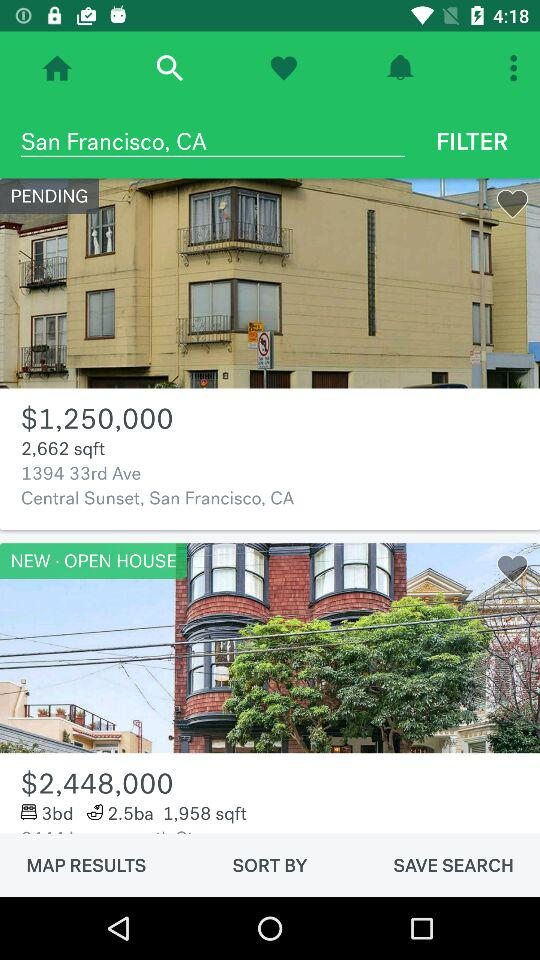Which city is entered? The entered city is San Francisco. 